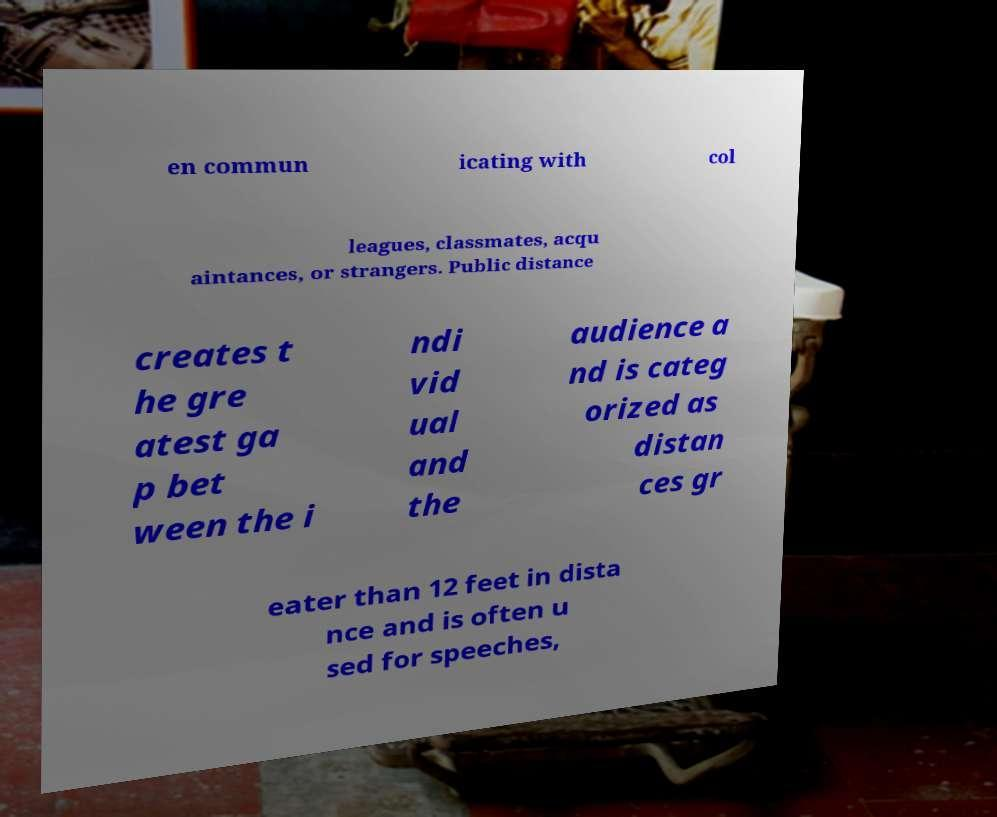There's text embedded in this image that I need extracted. Can you transcribe it verbatim? en commun icating with col leagues, classmates, acqu aintances, or strangers. Public distance creates t he gre atest ga p bet ween the i ndi vid ual and the audience a nd is categ orized as distan ces gr eater than 12 feet in dista nce and is often u sed for speeches, 